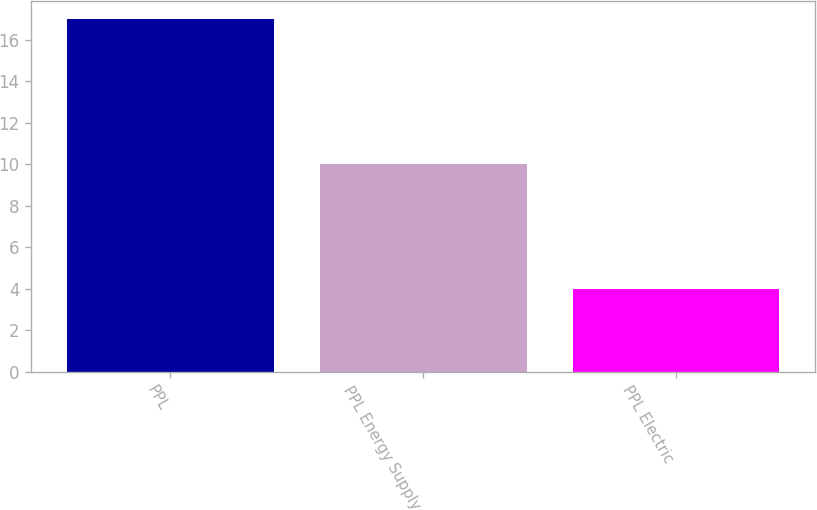Convert chart. <chart><loc_0><loc_0><loc_500><loc_500><bar_chart><fcel>PPL<fcel>PPL Energy Supply<fcel>PPL Electric<nl><fcel>17<fcel>10<fcel>4<nl></chart> 